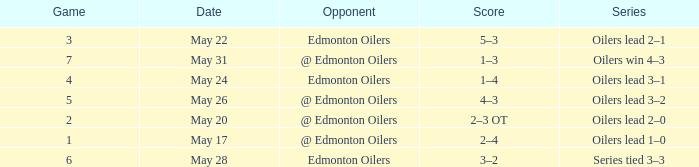Opponent of edmonton oilers, and a Game of 3 is what series? Oilers lead 2–1. 